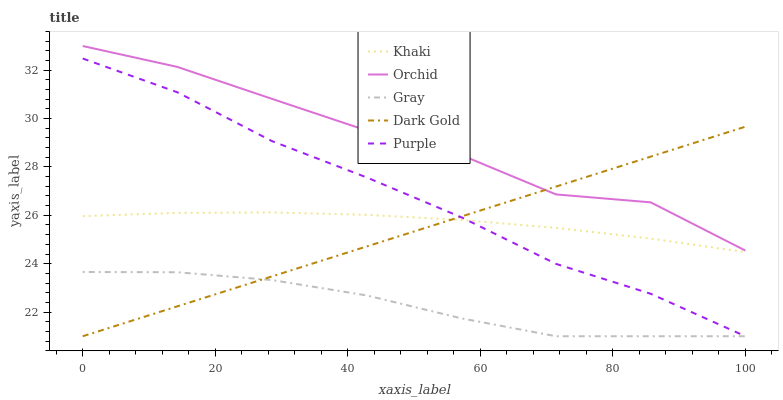Does Gray have the minimum area under the curve?
Answer yes or no. Yes. Does Orchid have the maximum area under the curve?
Answer yes or no. Yes. Does Khaki have the minimum area under the curve?
Answer yes or no. No. Does Khaki have the maximum area under the curve?
Answer yes or no. No. Is Dark Gold the smoothest?
Answer yes or no. Yes. Is Orchid the roughest?
Answer yes or no. Yes. Is Gray the smoothest?
Answer yes or no. No. Is Gray the roughest?
Answer yes or no. No. Does Khaki have the lowest value?
Answer yes or no. No. Does Orchid have the highest value?
Answer yes or no. Yes. Does Khaki have the highest value?
Answer yes or no. No. Is Gray less than Khaki?
Answer yes or no. Yes. Is Orchid greater than Khaki?
Answer yes or no. Yes. Does Gray intersect Khaki?
Answer yes or no. No. 